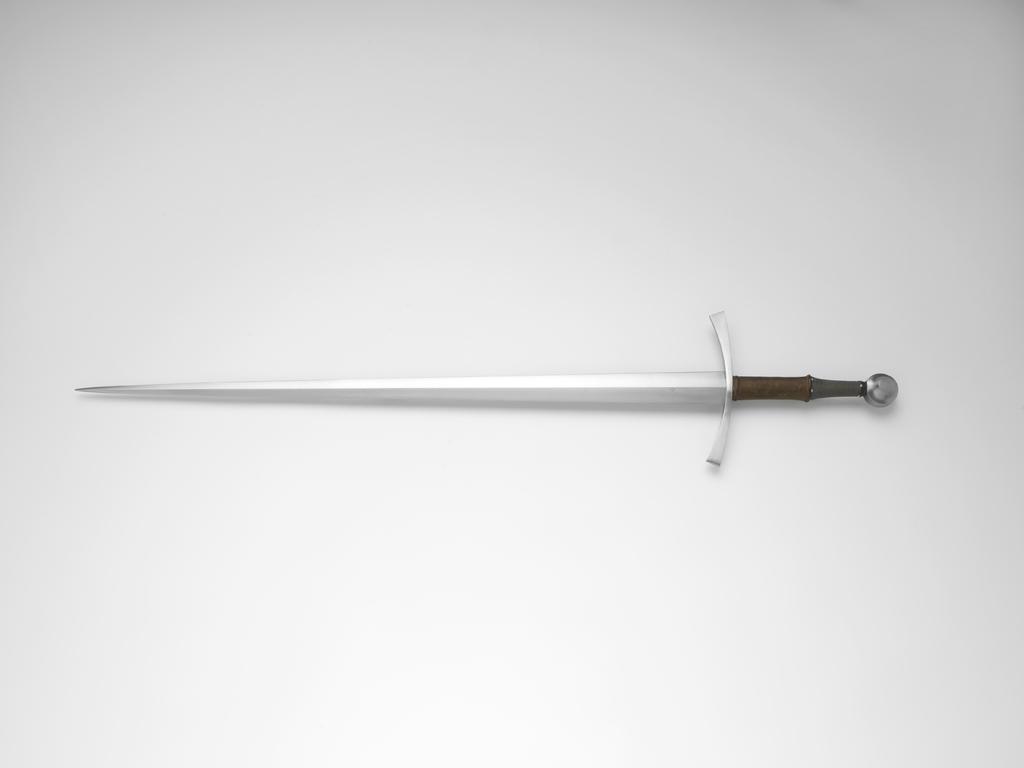Please provide a concise description of this image. In this image we can see a sword and the background is white. 